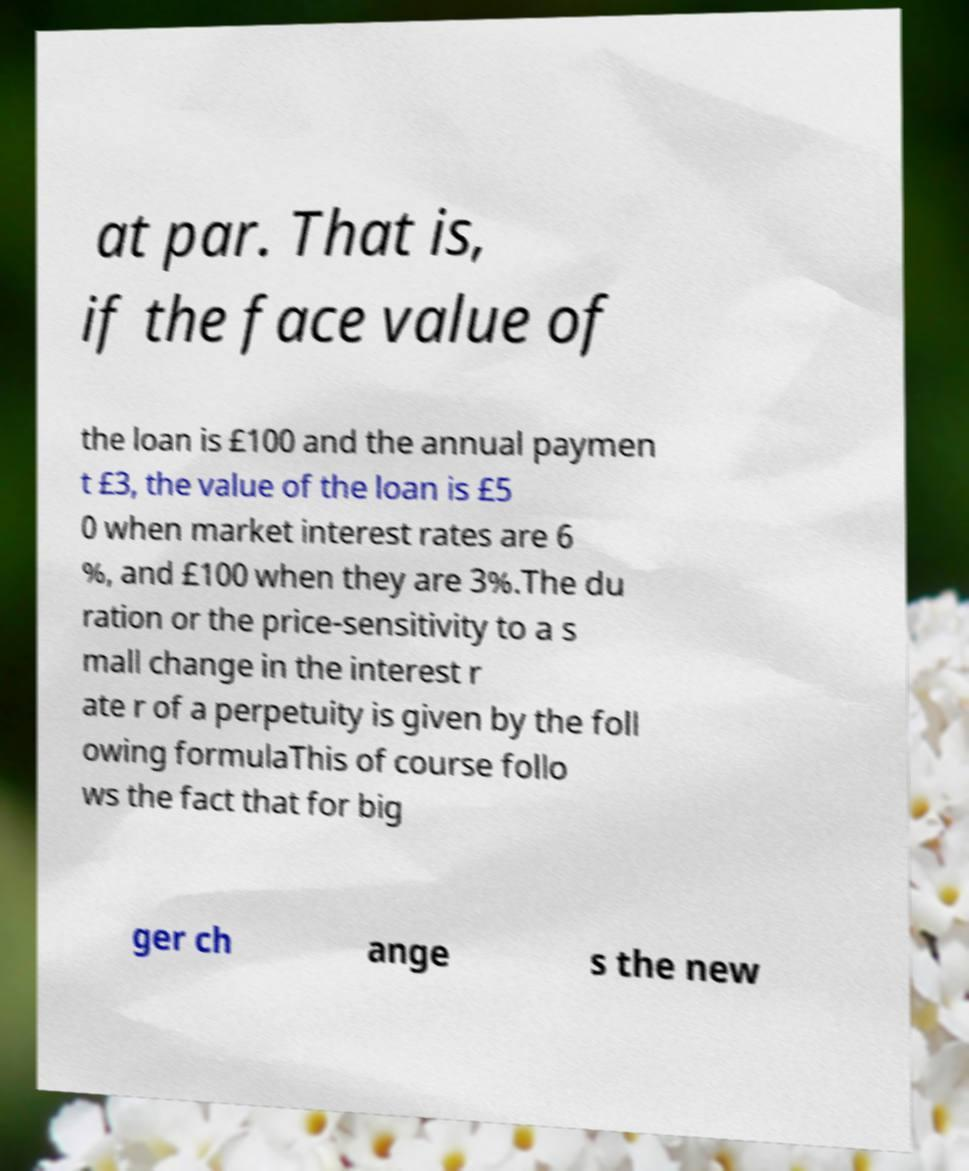Can you read and provide the text displayed in the image?This photo seems to have some interesting text. Can you extract and type it out for me? at par. That is, if the face value of the loan is £100 and the annual paymen t £3, the value of the loan is £5 0 when market interest rates are 6 %, and £100 when they are 3%.The du ration or the price-sensitivity to a s mall change in the interest r ate r of a perpetuity is given by the foll owing formulaThis of course follo ws the fact that for big ger ch ange s the new 